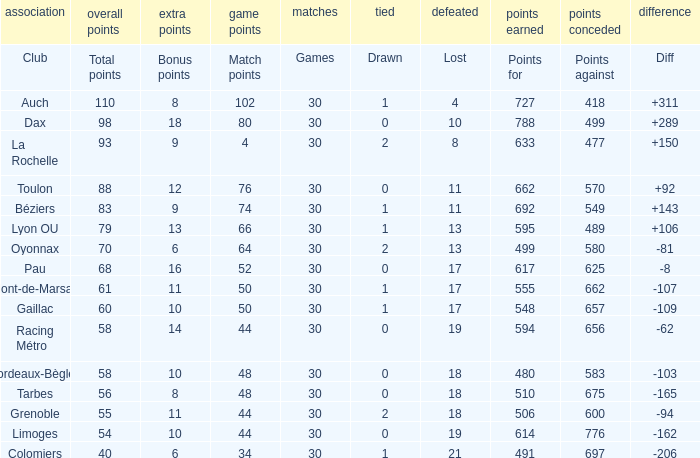What is the amount of match points for a club that lost 18 and has 11 bonus points? 44.0. 